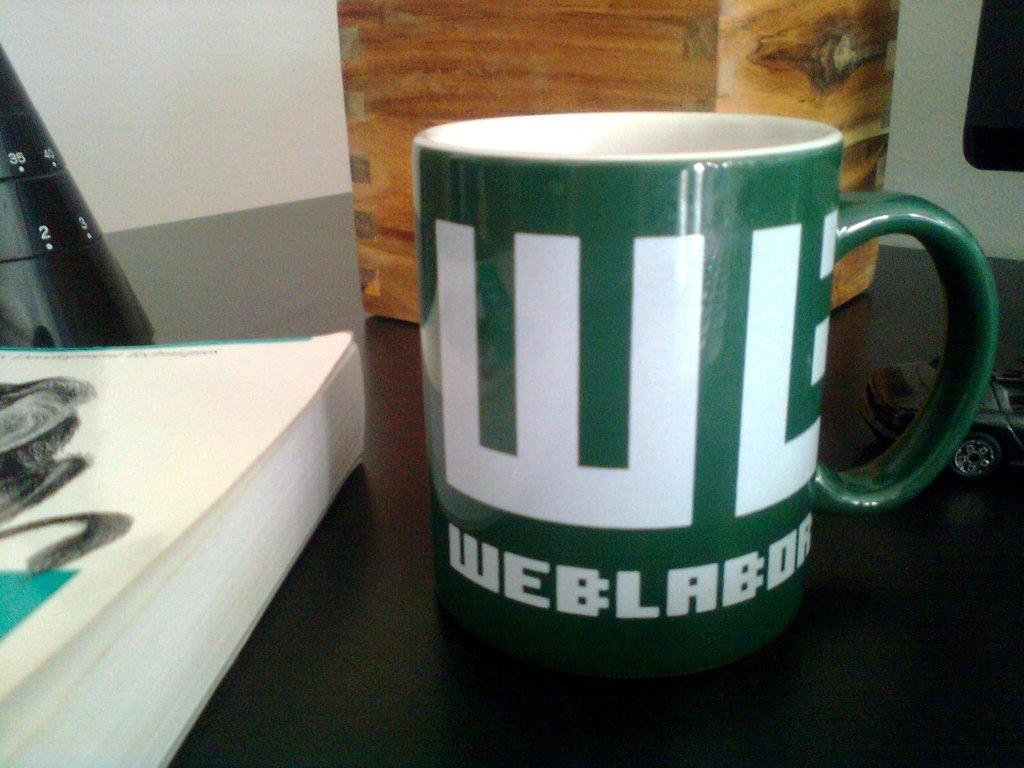<image>
Present a compact description of the photo's key features. A green coffe mug with the initials WB in bold lettering. 